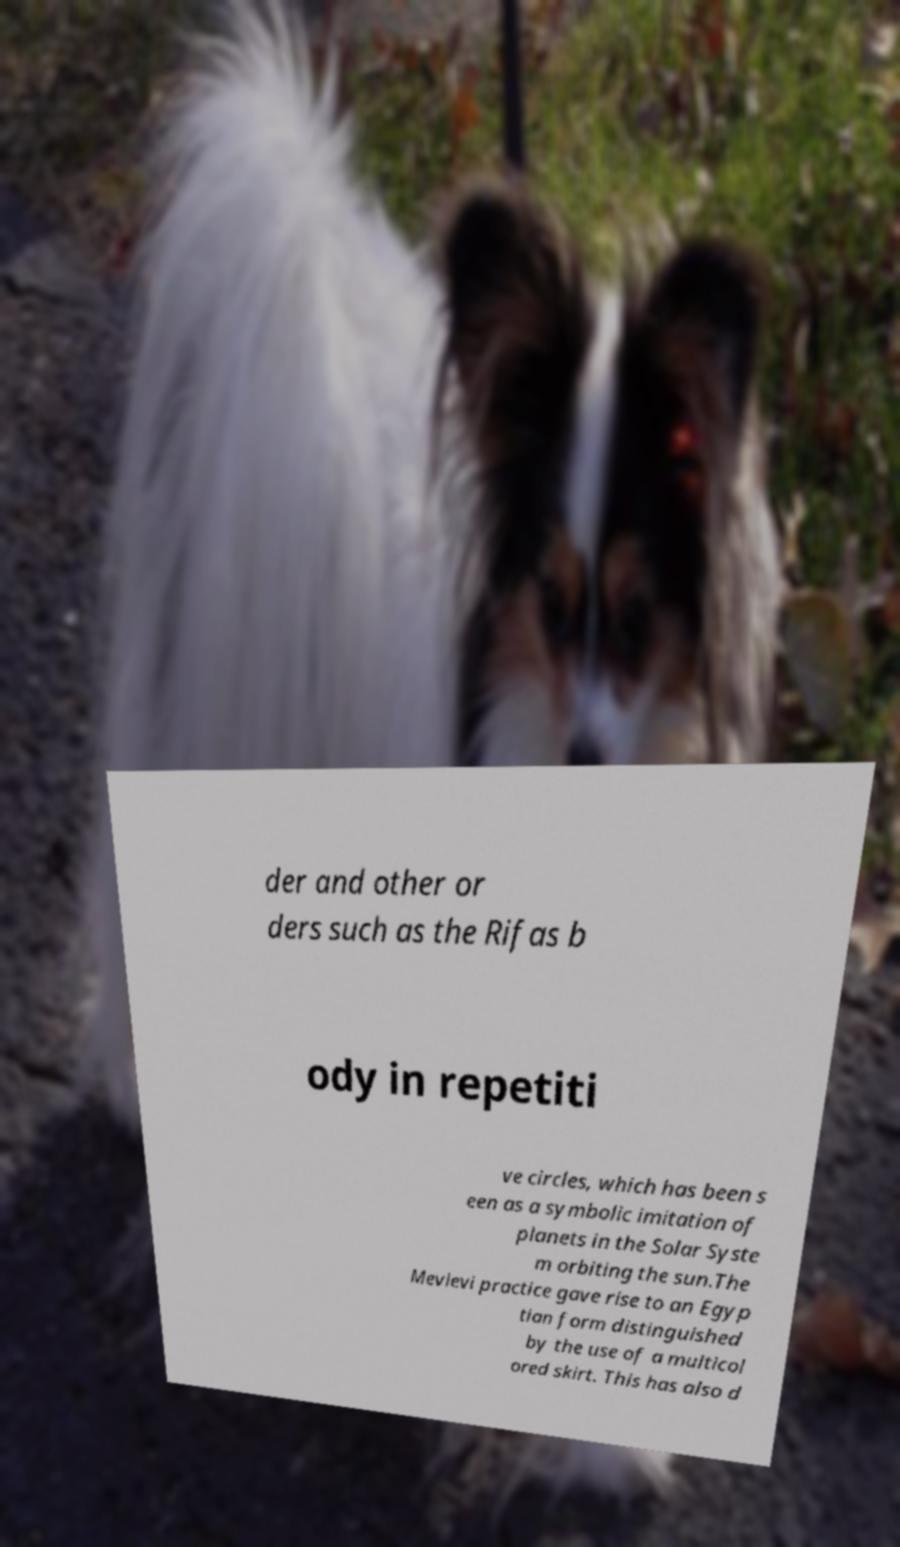Please read and relay the text visible in this image. What does it say? der and other or ders such as the Rifas b ody in repetiti ve circles, which has been s een as a symbolic imitation of planets in the Solar Syste m orbiting the sun.The Mevlevi practice gave rise to an Egyp tian form distinguished by the use of a multicol ored skirt. This has also d 